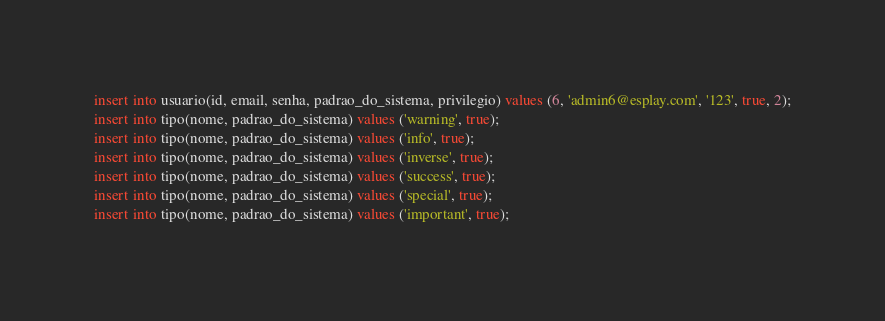<code> <loc_0><loc_0><loc_500><loc_500><_SQL_>insert into usuario(id, email, senha, padrao_do_sistema, privilegio) values (6, 'admin6@esplay.com', '123', true, 2);
insert into tipo(nome, padrao_do_sistema) values ('warning', true);
insert into tipo(nome, padrao_do_sistema) values ('info', true);
insert into tipo(nome, padrao_do_sistema) values ('inverse', true);
insert into tipo(nome, padrao_do_sistema) values ('success', true);
insert into tipo(nome, padrao_do_sistema) values ('special', true);
insert into tipo(nome, padrao_do_sistema) values ('important', true);</code> 